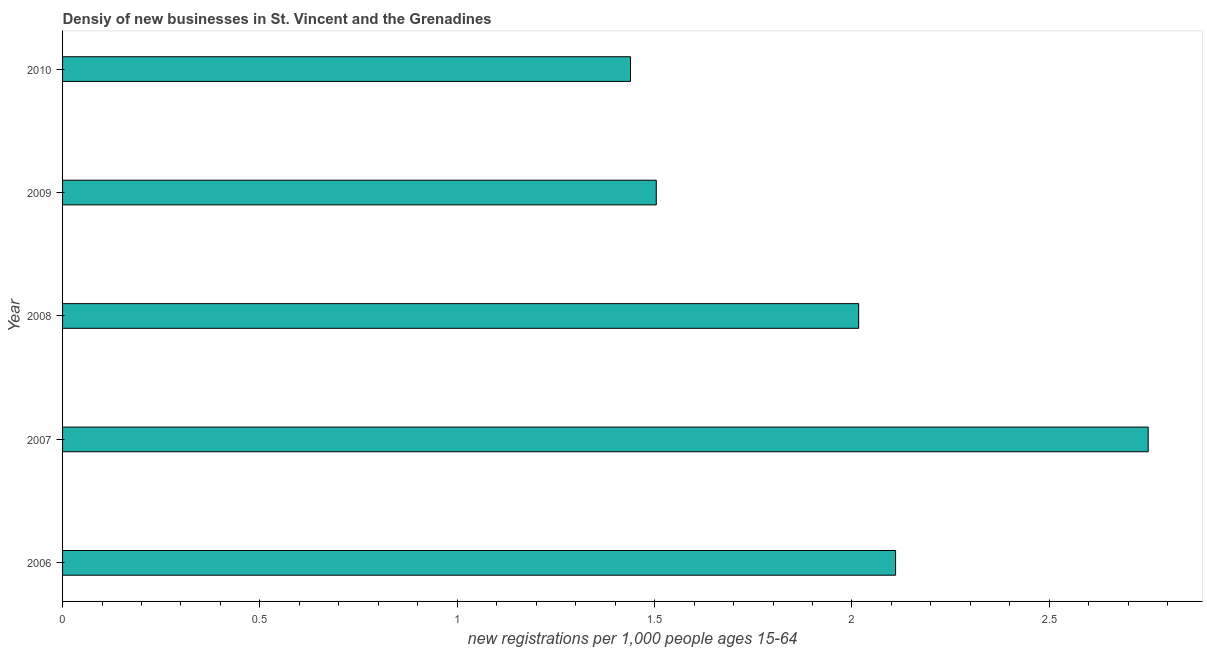What is the title of the graph?
Ensure brevity in your answer.  Densiy of new businesses in St. Vincent and the Grenadines. What is the label or title of the X-axis?
Ensure brevity in your answer.  New registrations per 1,0 people ages 15-64. What is the label or title of the Y-axis?
Ensure brevity in your answer.  Year. What is the density of new business in 2006?
Your answer should be very brief. 2.11. Across all years, what is the maximum density of new business?
Your answer should be very brief. 2.75. Across all years, what is the minimum density of new business?
Ensure brevity in your answer.  1.44. What is the sum of the density of new business?
Keep it short and to the point. 9.82. What is the difference between the density of new business in 2009 and 2010?
Provide a succinct answer. 0.07. What is the average density of new business per year?
Your response must be concise. 1.96. What is the median density of new business?
Offer a very short reply. 2.02. What is the ratio of the density of new business in 2008 to that in 2010?
Your answer should be compact. 1.4. What is the difference between the highest and the second highest density of new business?
Offer a terse response. 0.64. What is the difference between the highest and the lowest density of new business?
Your answer should be very brief. 1.31. In how many years, is the density of new business greater than the average density of new business taken over all years?
Ensure brevity in your answer.  3. How many bars are there?
Keep it short and to the point. 5. How many years are there in the graph?
Provide a short and direct response. 5. Are the values on the major ticks of X-axis written in scientific E-notation?
Offer a very short reply. No. What is the new registrations per 1,000 people ages 15-64 in 2006?
Your response must be concise. 2.11. What is the new registrations per 1,000 people ages 15-64 of 2007?
Give a very brief answer. 2.75. What is the new registrations per 1,000 people ages 15-64 of 2008?
Your answer should be compact. 2.02. What is the new registrations per 1,000 people ages 15-64 of 2009?
Make the answer very short. 1.5. What is the new registrations per 1,000 people ages 15-64 in 2010?
Offer a very short reply. 1.44. What is the difference between the new registrations per 1,000 people ages 15-64 in 2006 and 2007?
Your response must be concise. -0.64. What is the difference between the new registrations per 1,000 people ages 15-64 in 2006 and 2008?
Keep it short and to the point. 0.09. What is the difference between the new registrations per 1,000 people ages 15-64 in 2006 and 2009?
Your answer should be compact. 0.61. What is the difference between the new registrations per 1,000 people ages 15-64 in 2006 and 2010?
Offer a very short reply. 0.67. What is the difference between the new registrations per 1,000 people ages 15-64 in 2007 and 2008?
Offer a very short reply. 0.73. What is the difference between the new registrations per 1,000 people ages 15-64 in 2007 and 2009?
Your answer should be compact. 1.25. What is the difference between the new registrations per 1,000 people ages 15-64 in 2007 and 2010?
Give a very brief answer. 1.31. What is the difference between the new registrations per 1,000 people ages 15-64 in 2008 and 2009?
Provide a succinct answer. 0.51. What is the difference between the new registrations per 1,000 people ages 15-64 in 2008 and 2010?
Ensure brevity in your answer.  0.58. What is the difference between the new registrations per 1,000 people ages 15-64 in 2009 and 2010?
Make the answer very short. 0.07. What is the ratio of the new registrations per 1,000 people ages 15-64 in 2006 to that in 2007?
Offer a very short reply. 0.77. What is the ratio of the new registrations per 1,000 people ages 15-64 in 2006 to that in 2008?
Provide a succinct answer. 1.05. What is the ratio of the new registrations per 1,000 people ages 15-64 in 2006 to that in 2009?
Offer a terse response. 1.4. What is the ratio of the new registrations per 1,000 people ages 15-64 in 2006 to that in 2010?
Give a very brief answer. 1.47. What is the ratio of the new registrations per 1,000 people ages 15-64 in 2007 to that in 2008?
Offer a terse response. 1.36. What is the ratio of the new registrations per 1,000 people ages 15-64 in 2007 to that in 2009?
Keep it short and to the point. 1.83. What is the ratio of the new registrations per 1,000 people ages 15-64 in 2007 to that in 2010?
Make the answer very short. 1.91. What is the ratio of the new registrations per 1,000 people ages 15-64 in 2008 to that in 2009?
Ensure brevity in your answer.  1.34. What is the ratio of the new registrations per 1,000 people ages 15-64 in 2008 to that in 2010?
Your response must be concise. 1.4. What is the ratio of the new registrations per 1,000 people ages 15-64 in 2009 to that in 2010?
Offer a terse response. 1.04. 